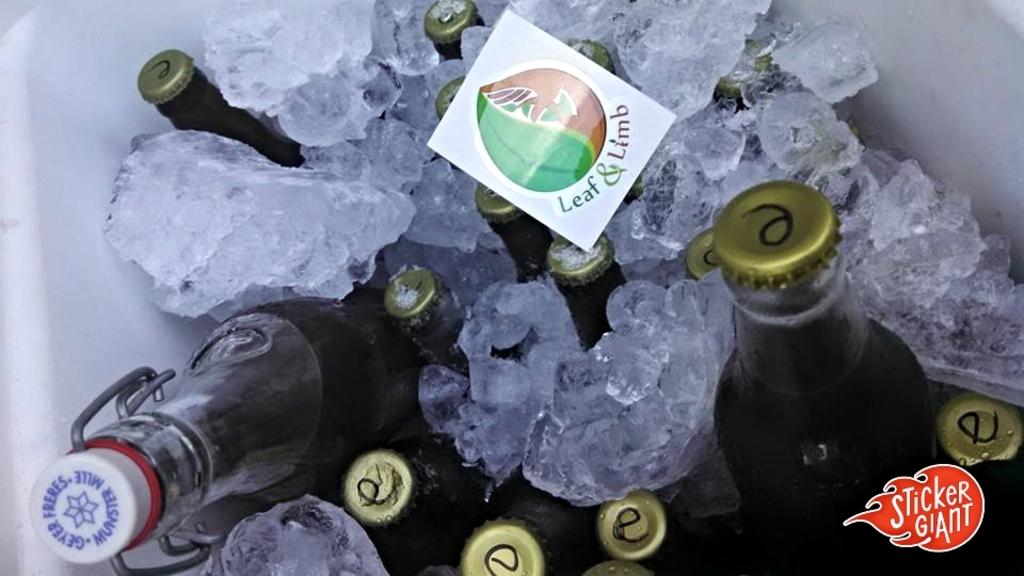Does leaf & limb make beer?
Provide a short and direct response. Unanswerable. This says sticker what?
Your answer should be very brief. Leaf & limb. 